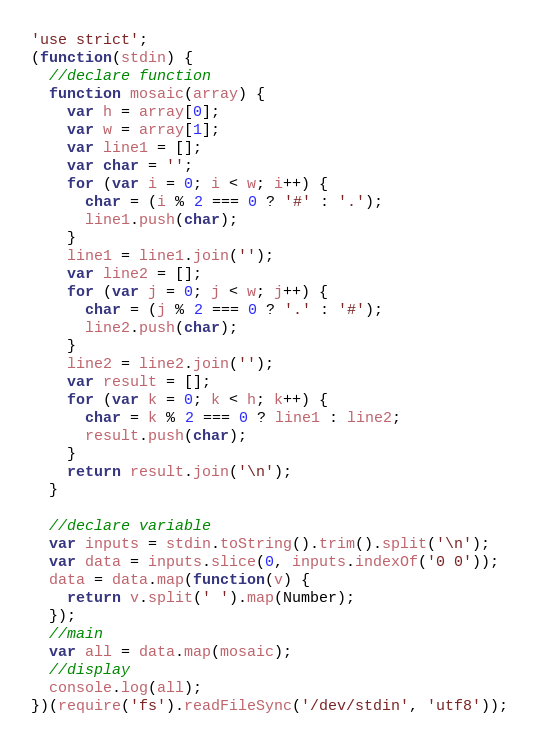<code> <loc_0><loc_0><loc_500><loc_500><_JavaScript_>'use strict';
(function(stdin) {
  //declare function
  function mosaic(array) {
    var h = array[0];
    var w = array[1];
    var line1 = [];
    var char = '';
    for (var i = 0; i < w; i++) {
      char = (i % 2 === 0 ? '#' : '.');
      line1.push(char);
    }
    line1 = line1.join('');
    var line2 = [];
    for (var j = 0; j < w; j++) {
      char = (j % 2 === 0 ? '.' : '#');
      line2.push(char);
    }
    line2 = line2.join('');
    var result = [];
    for (var k = 0; k < h; k++) {
      char = k % 2 === 0 ? line1 : line2;
      result.push(char);
    }
    return result.join('\n');
  }

  //declare variable
  var inputs = stdin.toString().trim().split('\n');
  var data = inputs.slice(0, inputs.indexOf('0 0'));
  data = data.map(function(v) {
    return v.split(' ').map(Number);
  });
  //main
  var all = data.map(mosaic);
  //display
  console.log(all);
})(require('fs').readFileSync('/dev/stdin', 'utf8'));</code> 